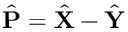<formula> <loc_0><loc_0><loc_500><loc_500>\hat { \mathbf P } = \hat { \mathbf X } - \hat { \mathbf Y }</formula> 